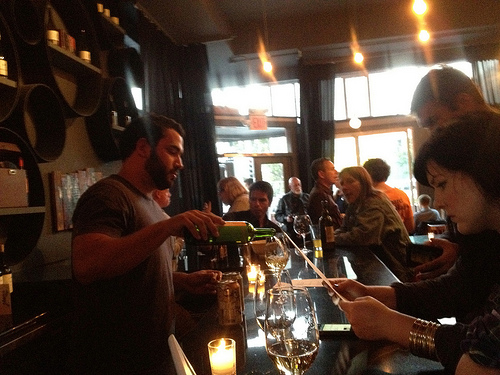<image>
Is the phone under the bottle? No. The phone is not positioned under the bottle. The vertical relationship between these objects is different. Is the bottle behind the man? Yes. From this viewpoint, the bottle is positioned behind the man, with the man partially or fully occluding the bottle. Is the man behind the window? No. The man is not behind the window. From this viewpoint, the man appears to be positioned elsewhere in the scene. 